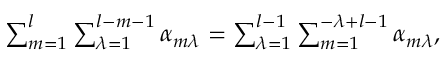Convert formula to latex. <formula><loc_0><loc_0><loc_500><loc_500>\begin{array} { r } { \sum _ { m = 1 } ^ { l } \sum _ { \lambda = 1 } ^ { l - m - 1 } \alpha _ { m \lambda } = \sum _ { \lambda = 1 } ^ { l - 1 } \sum _ { m = 1 } ^ { - \lambda + l - 1 } \alpha _ { m \lambda } , } \end{array}</formula> 